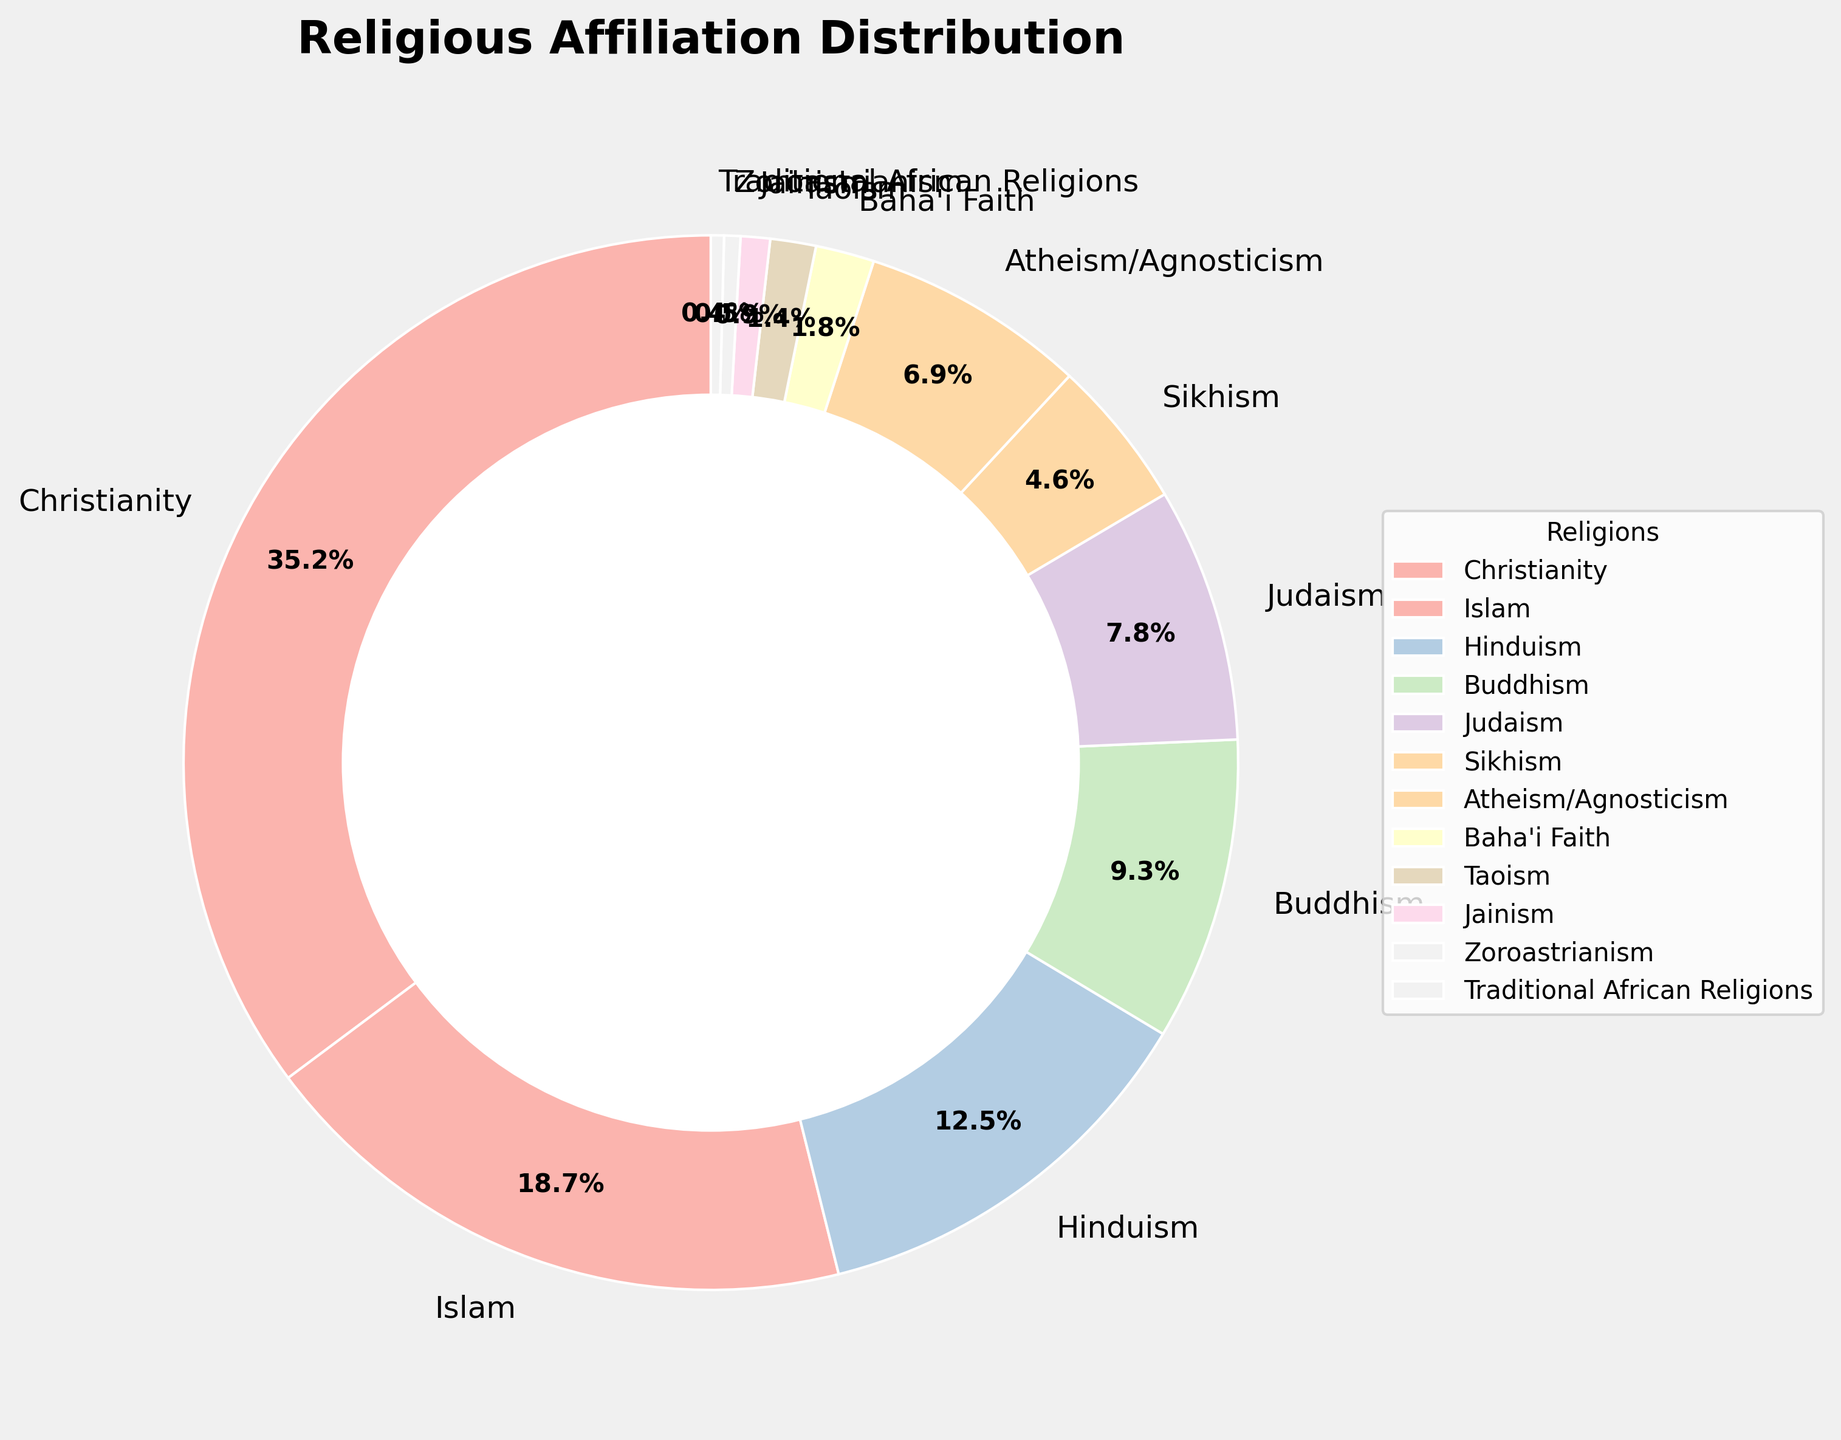What religious group has the highest percentage? The pie chart shows that Christianity has the largest segment of the pie, indicating it has the highest percentage.
Answer: Christianity Which two religions have nearly equal representation? The segments for Judaism and Atheism/Agnosticism are quite similar in size, suggesting their percentages are close.
Answer: Judaism and Atheism/Agnosticism How many religions have a percentage greater than 10%? By observing the pie chart, we see the segments for Christianity, Islam, and Hinduism each exceed 10%.
Answer: 3 What is the combined percentage of Buddhism and Sikhism? Adding the segments labeled Buddhism (9.3%) and Sikhism (4.6%) together gives a combined percentage of 9.3 + 4.6 = 13.9%.
Answer: 13.9% Which religion has the smallest percentage? The smallest segment of the pie chart corresponds to Traditional African Religions, which is labeled as 0.4%.
Answer: Traditional African Religions How does the percentage of Islam compare to that of Hinduism? Islam is represented with 18.7%, while Hinduism has 12.5%. Islam has a higher percentage compared to Hinduism.
Answer: Islam has a higher percentage than Hinduism What is the total percentage for religions with less than 2% representation? Adding the segments for Baha'i Faith (1.8%), Taoism (1.4%), Jainism (0.9%), Zoroastrianism (0.5%), and Traditional African Religions (0.4%): 1.8 + 1.4 + 0.9 + 0.5 + 0.4 = 5.0%.
Answer: 5.0% Which religions have a combined representation that exceeds Christianity's percentage when summed? Adding the percentages for Islam (18.7%) and Hinduism (12.5%) together results in 18.7 + 12.5 = 31.2%. This total is less than Christianity’s percentage (35.2%), but adding another religion such as Buddhism (9.3%) tips the balance. Thus, Islam (18.7%), Hinduism (12.5%), and Buddhism (9.3%) combined: 18.7 + 12.5 + 9.3 = 40.5%, which is more than 35.2%.
Answer: Islam, Hinduism, and Buddhism What is the difference in percentage between the largest and smallest represented religious groups? Christianity is the largest represented group at 35.2% and Traditional African Religions is the smallest at 0.4%. The difference is 35.2 - 0.4 = 34.8%.
Answer: 34.8% 